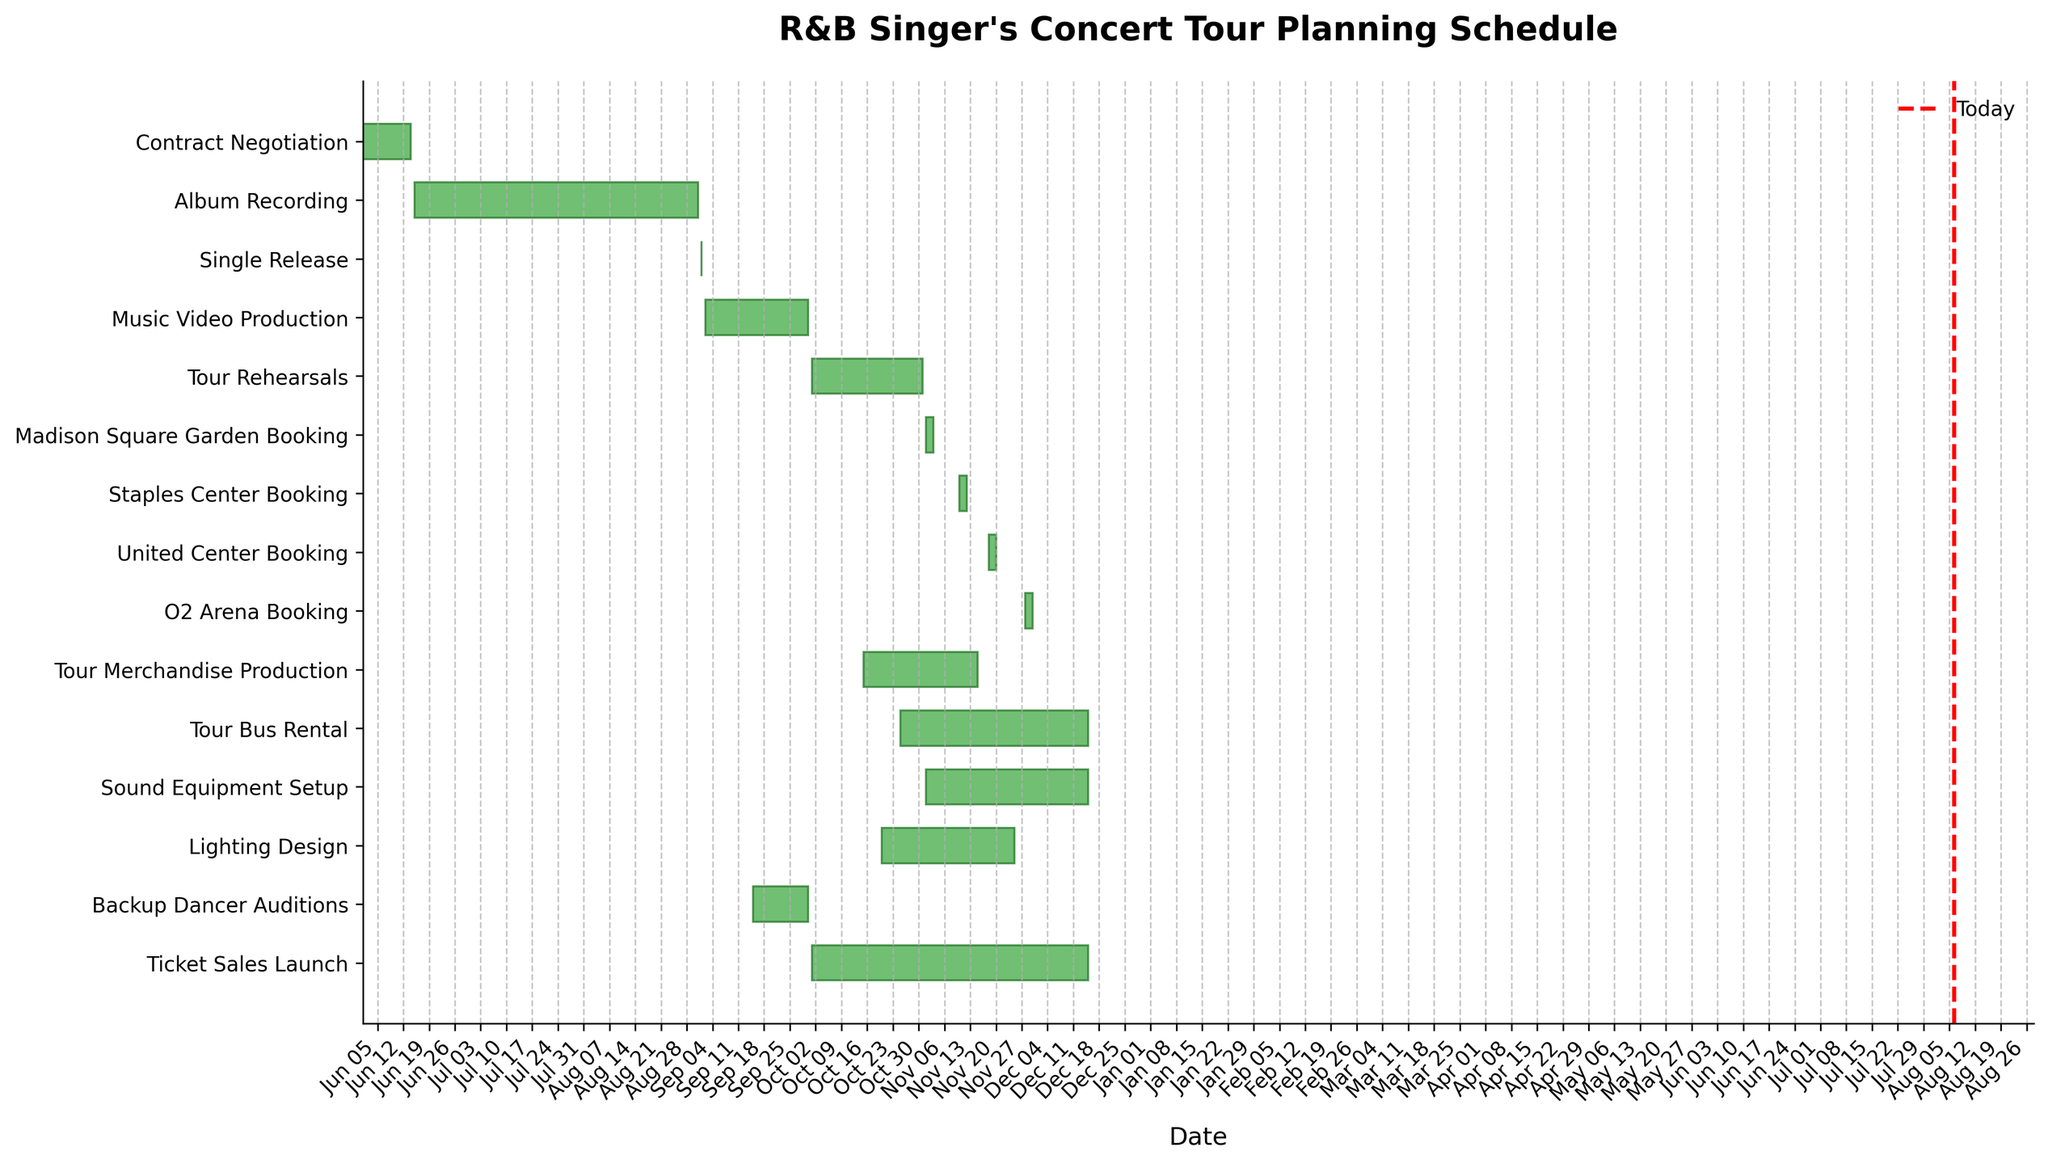What is the title of the figure? The title is usually located at the top of the plot. In this case, the Gantt chart is titled "R&B Singer's Concert Tour Planning Schedule."
Answer: R&B Singer's Concert Tour Planning Schedule Which task spans the longest duration? To find this, look at the length of the horizontal bars in the Gantt chart. The "Album Recording" task has the longest duration from June 15 to August 31.
Answer: Album Recording What are the start and end dates for the Tour Bus Rental task? Refer to the leftmost and rightmost points of the "Tour Bus Rental" bar on the Gantt chart. It starts on October 25 and ends on December 15.
Answer: October 25 to December 15 How many tasks are scheduled to start on October 1? Look along the vertical line corresponding to October 1 and count the tasks that start on that date. There are two tasks: "Tour Rehearsals" and "Ticket Sales Launch."
Answer: 2 Which tasks are scheduled to be completed by November 15? Identify tasks with end dates on or before November 15 by looking at the right end of the bars. These include "Contract Negotiation," "Album Recording," "Single Release," "Music Video Production," "Backup Dancer Auditions," "Tour Rehearsals," "Madison Square Garden Booking," and "Tour Merchandise Production."
Answer: 8 tasks What time frame does Sound Equipment Setup cover? Look at the starting point and the end point of the "Sound Equipment Setup" bar on the chart, which spans from November 1 to December 15.
Answer: November 1 to December 15 Which two tasks overlap exactly in their start and end dates? Find bars that start and end simultaneously. Both "Tour Bus Rental" and "Ticket Sales Launch" share the exact dates from October 1 to December 15.
Answer: Tour Bus Rental and Ticket Sales Launch Compare the durations of the Madison Square Garden Booking and O2 Arena Booking. Which is longer? Calculate the duration by counting the days of each task. Madison Square Garden Booking covers 3 days, while O2 Arena Booking also covers 3 days. Therefore, their durations are equal.
Answer: Equal If today's date is November 1, how many tasks have already started by today? Look to the left of the vertical line marking today’s date. Count the tasks that have started. There are eleven tasks: "Contract Negotiation," "Album Recording," "Single Release," "Music Video Production," "Tour Rehearsals," "Tour Merchandise Production," "Backup Dancer Auditions," "Ticket Sales Launch," "Tour Bus Rental," "Lighting Design," and "Sound Equipment Setup."
Answer: 11 tasks During which months does the Album Recording take place? Identify the start and end dates of the "Album Recording" task and note the covered months. It spans from June 15 to August 31, covering June, July, and August.
Answer: June, July, August 